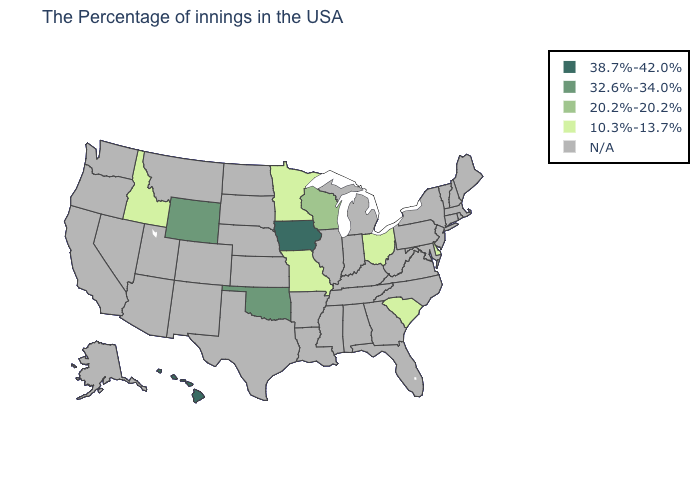What is the highest value in states that border Wyoming?
Be succinct. 10.3%-13.7%. Which states have the highest value in the USA?
Quick response, please. Iowa, Hawaii. How many symbols are there in the legend?
Quick response, please. 5. What is the value of Louisiana?
Concise answer only. N/A. Name the states that have a value in the range 20.2%-20.2%?
Concise answer only. Wisconsin. What is the value of Wisconsin?
Short answer required. 20.2%-20.2%. What is the highest value in states that border Idaho?
Write a very short answer. 32.6%-34.0%. What is the highest value in the West ?
Be succinct. 38.7%-42.0%. Name the states that have a value in the range 32.6%-34.0%?
Concise answer only. Oklahoma, Wyoming. Name the states that have a value in the range N/A?
Short answer required. Maine, Massachusetts, Rhode Island, New Hampshire, Vermont, Connecticut, New York, New Jersey, Maryland, Pennsylvania, Virginia, North Carolina, West Virginia, Florida, Georgia, Michigan, Kentucky, Indiana, Alabama, Tennessee, Illinois, Mississippi, Louisiana, Arkansas, Kansas, Nebraska, Texas, South Dakota, North Dakota, Colorado, New Mexico, Utah, Montana, Arizona, Nevada, California, Washington, Oregon, Alaska. Which states have the lowest value in the USA?
Concise answer only. Delaware, South Carolina, Ohio, Missouri, Minnesota, Idaho. How many symbols are there in the legend?
Answer briefly. 5. What is the value of New Jersey?
Keep it brief. N/A. What is the value of Missouri?
Give a very brief answer. 10.3%-13.7%. 